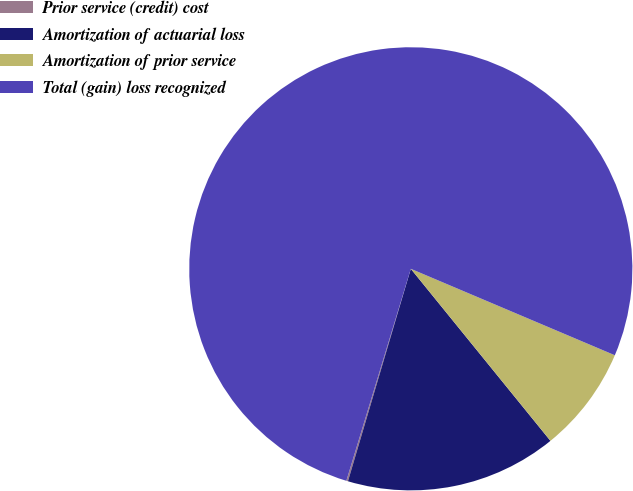Convert chart to OTSL. <chart><loc_0><loc_0><loc_500><loc_500><pie_chart><fcel>Prior service (credit) cost<fcel>Amortization of actuarial loss<fcel>Amortization of prior service<fcel>Total (gain) loss recognized<nl><fcel>0.12%<fcel>15.43%<fcel>7.77%<fcel>76.68%<nl></chart> 